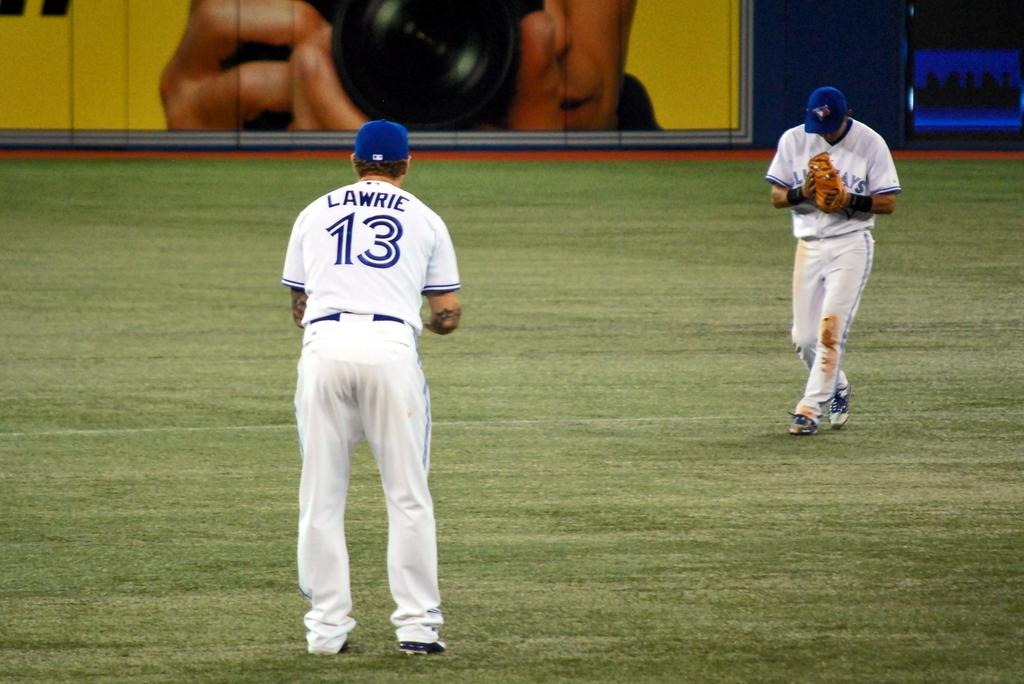<image>
Render a clear and concise summary of the photo. Men in white uniforms with the number 13 in blue. 